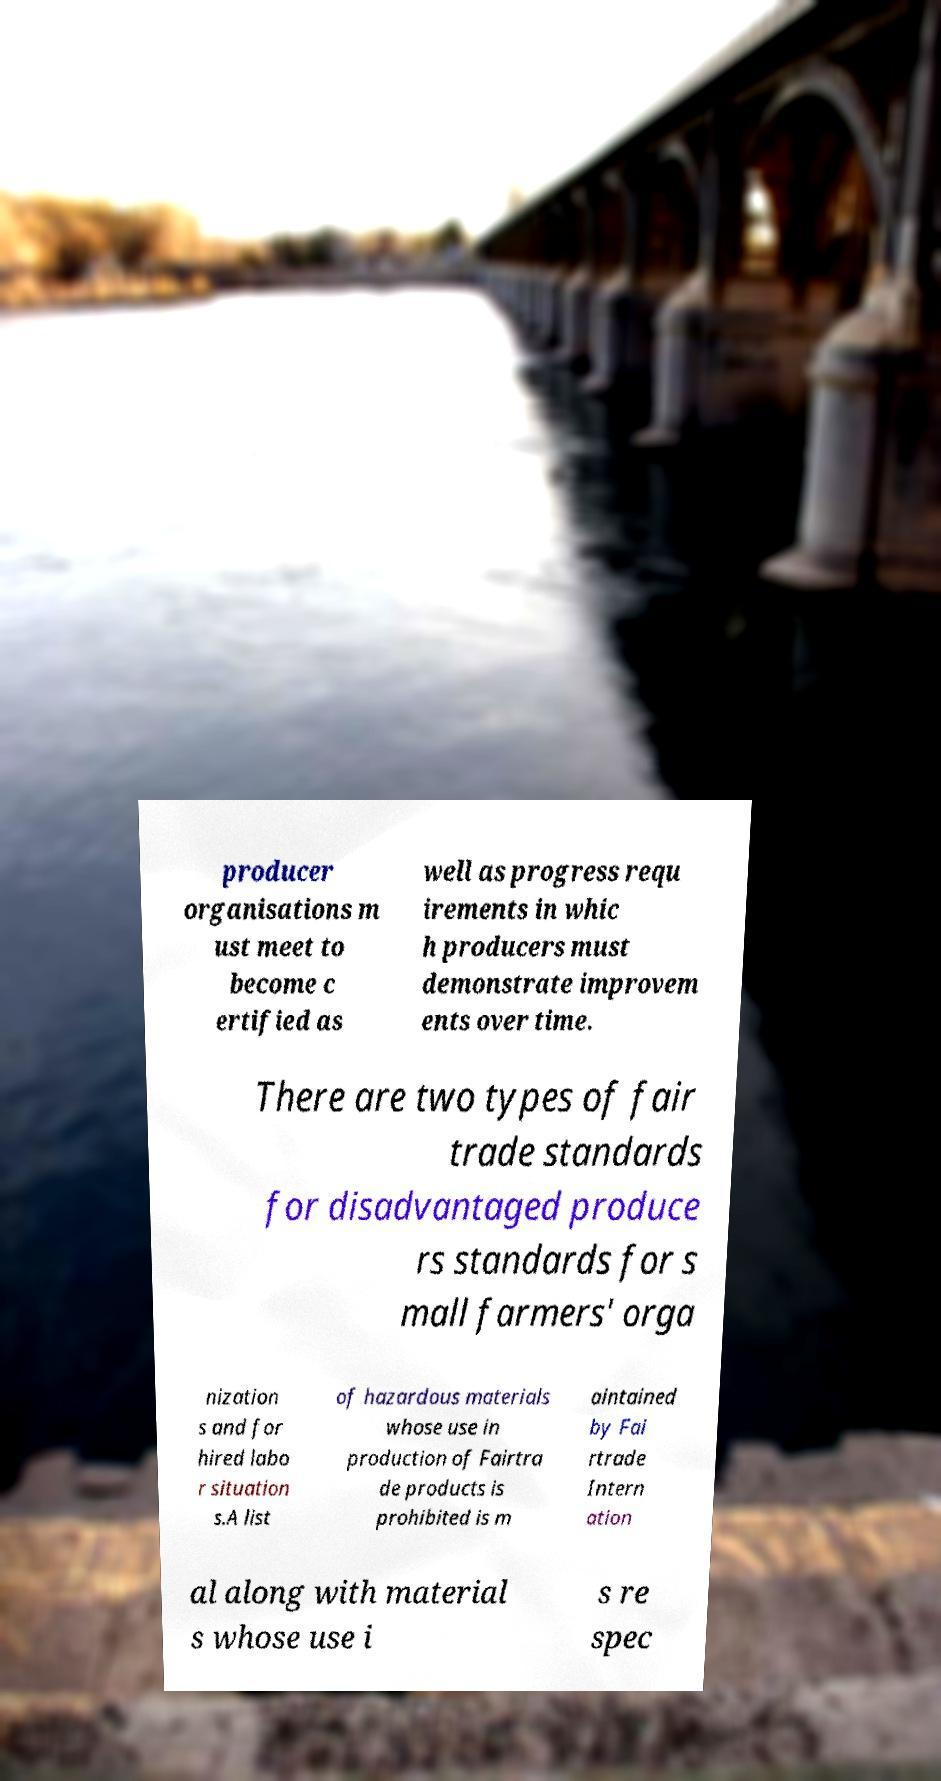Can you read and provide the text displayed in the image?This photo seems to have some interesting text. Can you extract and type it out for me? producer organisations m ust meet to become c ertified as well as progress requ irements in whic h producers must demonstrate improvem ents over time. There are two types of fair trade standards for disadvantaged produce rs standards for s mall farmers' orga nization s and for hired labo r situation s.A list of hazardous materials whose use in production of Fairtra de products is prohibited is m aintained by Fai rtrade Intern ation al along with material s whose use i s re spec 